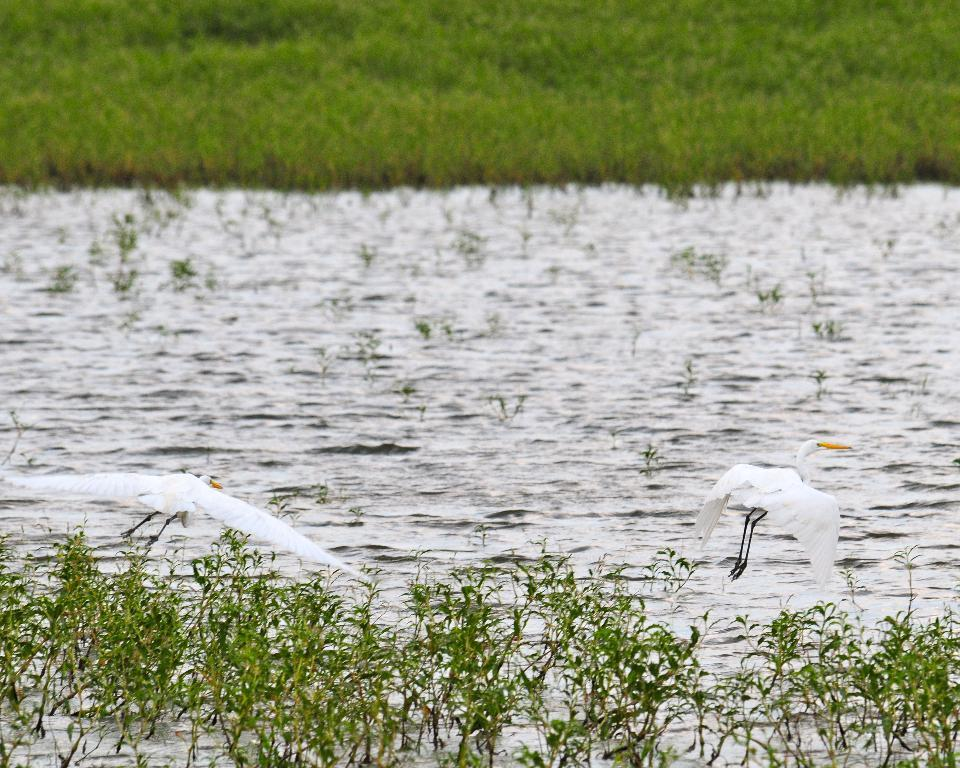What is the main subject in the center of the image? There is water in the center of the image. What other elements can be seen in the image? There are plants and two birds flying in the image. What type of vegetation is visible in the background? There is grass visible in the background of the image. Where is the crown located in the image? There is no crown present in the image. Can you tell me how much salt is in the water in the image? There is no information about the salt content in the water in the image. 